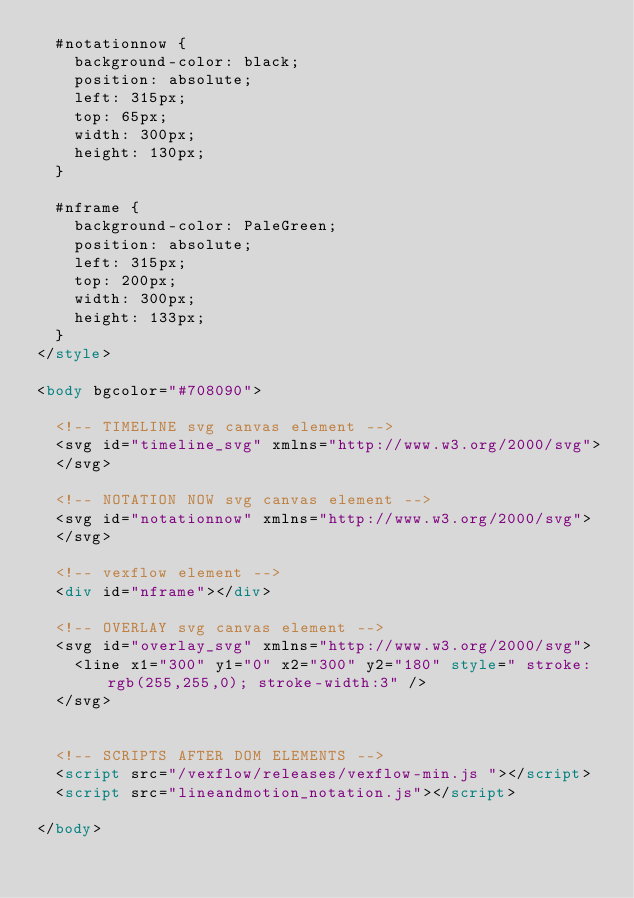Convert code to text. <code><loc_0><loc_0><loc_500><loc_500><_HTML_>  #notationnow {
    background-color: black;
    position: absolute;
    left: 315px;
    top: 65px;
    width: 300px;
    height: 130px;
  }

  #nframe {
    background-color: PaleGreen;
    position: absolute;
    left: 315px;
    top: 200px;
    width: 300px;
    height: 133px;
  }
</style>

<body bgcolor="#708090">

  <!-- TIMELINE svg canvas element -->
  <svg id="timeline_svg" xmlns="http://www.w3.org/2000/svg">
  </svg>

  <!-- NOTATION NOW svg canvas element -->
  <svg id="notationnow" xmlns="http://www.w3.org/2000/svg">
  </svg>

  <!-- vexflow element -->
  <div id="nframe"></div>

  <!-- OVERLAY svg canvas element -->
  <svg id="overlay_svg" xmlns="http://www.w3.org/2000/svg">
    <line x1="300" y1="0" x2="300" y2="180" style=" stroke:rgb(255,255,0); stroke-width:3" />
  </svg>


  <!-- SCRIPTS AFTER DOM ELEMENTS -->
  <script src="/vexflow/releases/vexflow-min.js "></script>
  <script src="lineandmotion_notation.js"></script>

</body>
</code> 